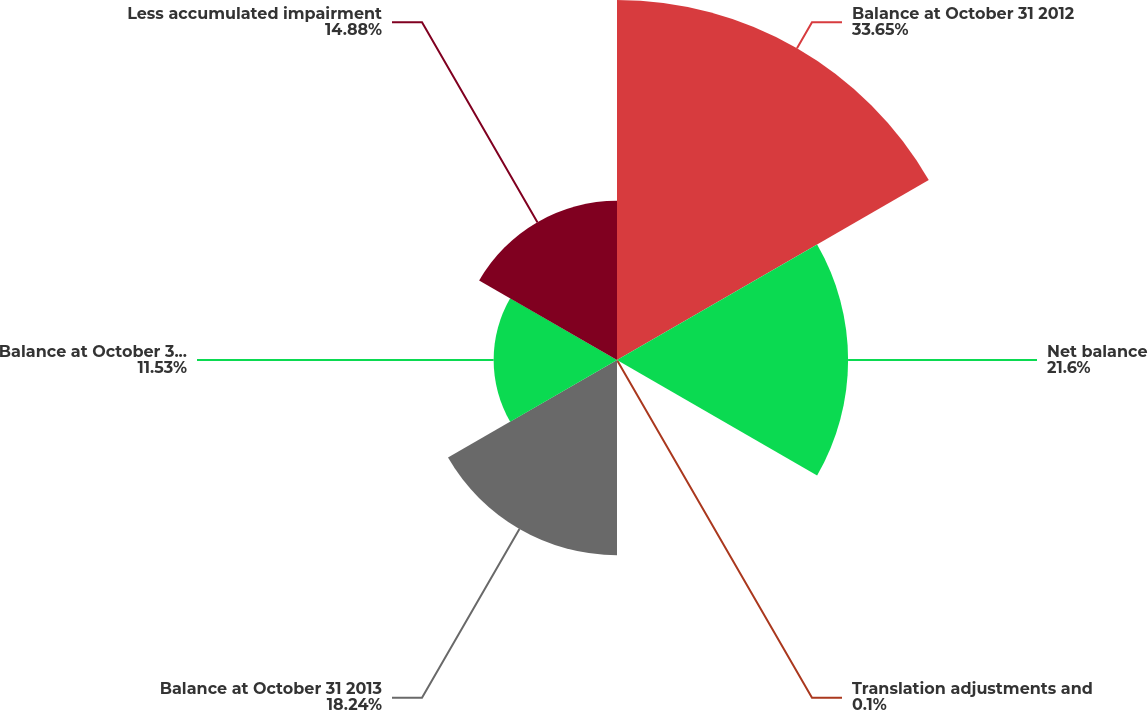Convert chart to OTSL. <chart><loc_0><loc_0><loc_500><loc_500><pie_chart><fcel>Balance at October 31 2012<fcel>Net balance<fcel>Translation adjustments and<fcel>Balance at October 31 2013<fcel>Balance at October 31 2014<fcel>Less accumulated impairment<nl><fcel>33.65%<fcel>21.6%<fcel>0.1%<fcel>18.24%<fcel>11.53%<fcel>14.88%<nl></chart> 